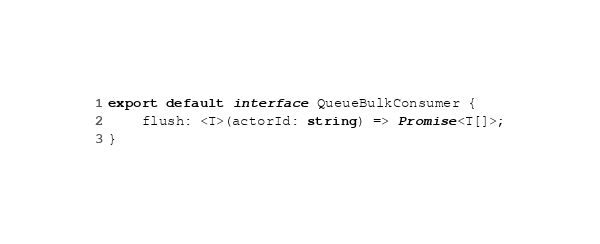<code> <loc_0><loc_0><loc_500><loc_500><_TypeScript_>export default interface QueueBulkConsumer {
    flush: <T>(actorId: string) => Promise<T[]>;
}
</code> 